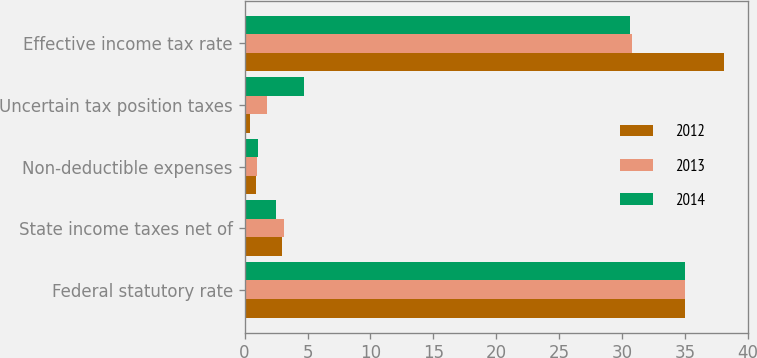<chart> <loc_0><loc_0><loc_500><loc_500><stacked_bar_chart><ecel><fcel>Federal statutory rate<fcel>State income taxes net of<fcel>Non-deductible expenses<fcel>Uncertain tax position taxes<fcel>Effective income tax rate<nl><fcel>2012<fcel>35<fcel>3<fcel>0.9<fcel>0.4<fcel>38.1<nl><fcel>2013<fcel>35<fcel>3.1<fcel>1<fcel>1.8<fcel>30.8<nl><fcel>2014<fcel>35<fcel>2.5<fcel>1.1<fcel>4.7<fcel>30.6<nl></chart> 